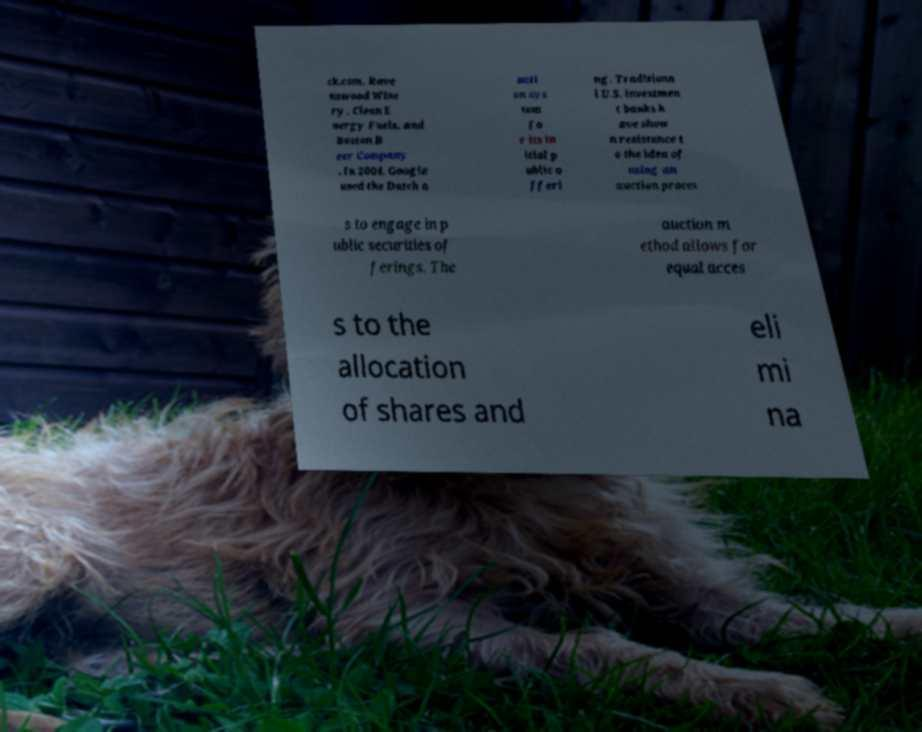Please read and relay the text visible in this image. What does it say? ck.com, Rave nswood Wine ry, Clean E nergy Fuels, and Boston B eer Company . In 2004, Google used the Dutch a ucti on sys tem fo r its in itial p ublic o fferi ng. Traditiona l U.S. investmen t banks h ave show n resistance t o the idea of using an auction proces s to engage in p ublic securities of ferings. The auction m ethod allows for equal acces s to the allocation of shares and eli mi na 